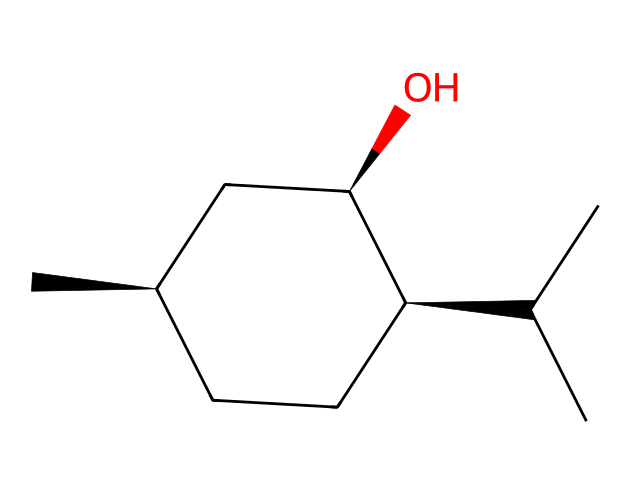What is the molecular formula of menthol? To determine the molecular formula, we can analyze the SMILES representation. Count the carbons (C), hydrogens (H), and oxygens (O) present in the structure. The structure presents 10 carbons, 20 hydrogens, and 1 oxygen, leading to the formula C10H20O.
Answer: C10H20O How many chiral centers are present in menthol? By examining the SMILES structure, we can identify the carbon atoms with four different substituents. The structure indicates three chiral centers, associated with specific configurations (denoted by the @ symbol in the SMILES).
Answer: 3 What functional group is present in menthol? Looking at the structure, the presence of the hydroxyl (-OH) group is the defining trait of alcohols, making it evident that menthol contains an alcohol functional group.
Answer: alcohol What is the degree of saturation in menthol? To find the degree of saturation, assess the number of rings and double bonds. This structure shows a saturated molecule with no rings or double bonds, leading to a degree of saturation of 1, as it is a single structural framework.
Answer: 1 What type of isomerism is exhibited by menthol? The presence of multiple chiral centers indicates that menthol can exist as stereoisomers, specifically optical isomers due to its asymmetric carbon atoms.
Answer: stereoisomerism 